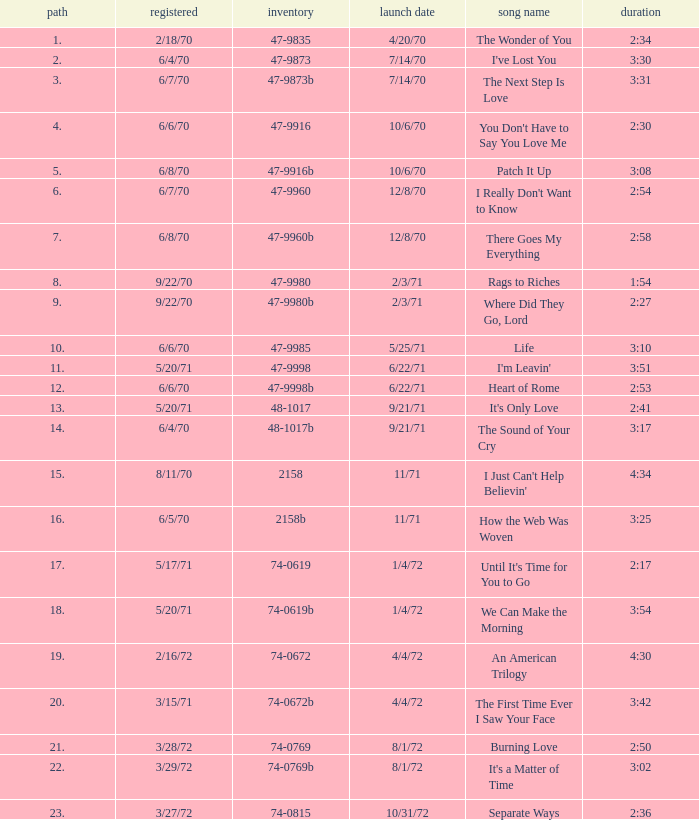What is the catalogue number for the song that is 3:17 and was released 9/21/71? 48-1017b. 